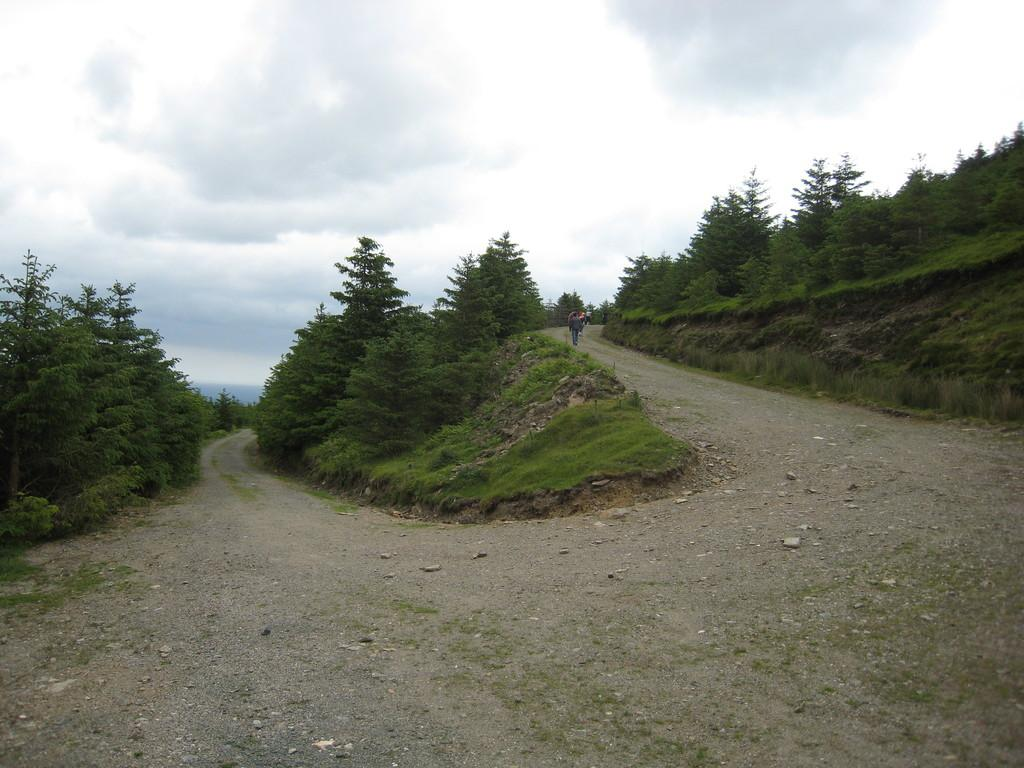What is the main feature of the image? There is a road in the image. What type of vegetation can be seen in the image? There is grass and green trees visible in the image. What are the people in the image doing? The people are standing on the road. What can be seen in the background of the image? The sky is visible in the background of the image. How does the wind affect the people standing on the road in the image? There is no mention of wind in the image, so we cannot determine its effect on the people. 